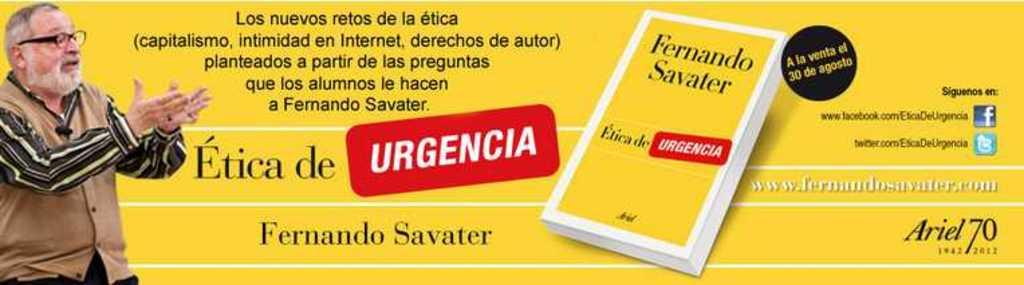What is present in the image that is promoting a product or service? There is a poster in the image that is an advertisement. Can you describe the poster in the image? The poster is an advertisement, but the specific details of the advertisement cannot be determined from the provided facts. What type of copper mountain can be seen in the image? There is no copper mountain present in the image. How does the pollution affect the advertisement in the image? There is no information about pollution in the image, and therefore its impact on the advertisement cannot be determined. 